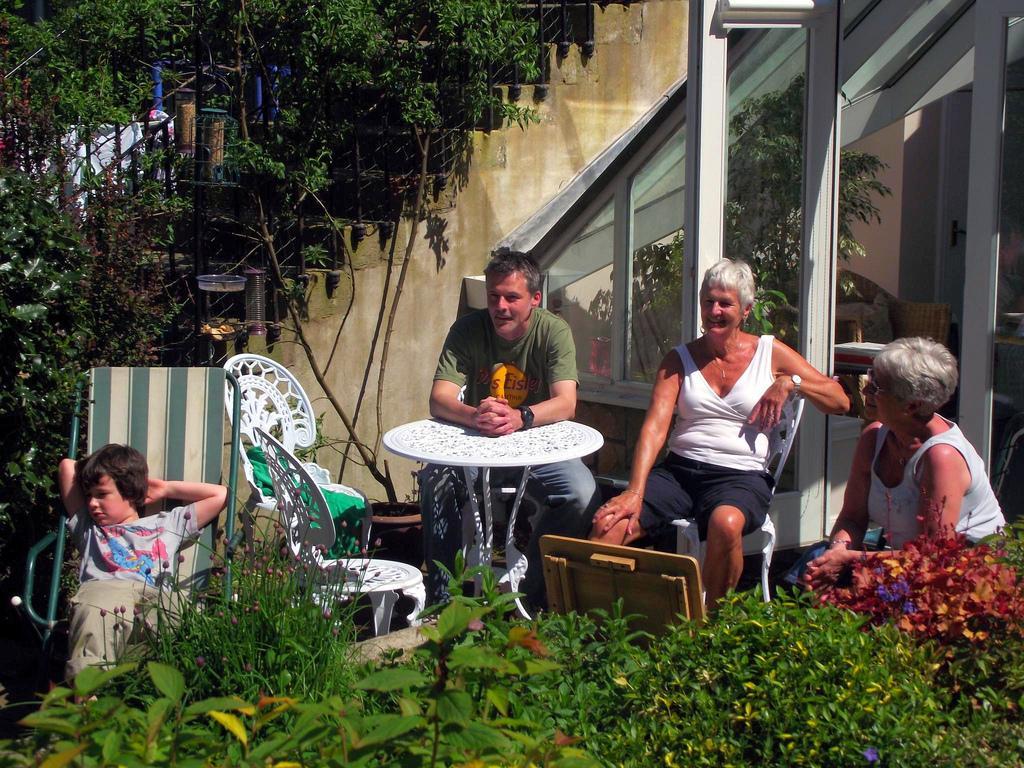How would you summarize this image in a sentence or two? This picture describes about four people they are seated on the chair, we can see couple of plants, table and a house. 